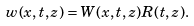Convert formula to latex. <formula><loc_0><loc_0><loc_500><loc_500>w ( x , t , z ) = W ( x , t , z ) R ( t , z ) .</formula> 